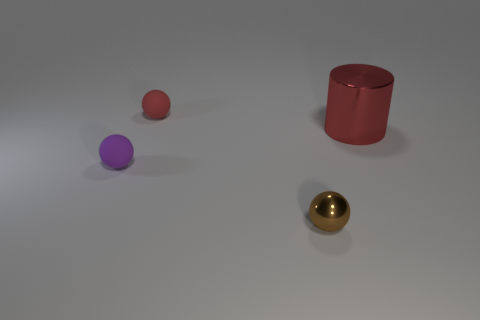Are there any objects that have the same material as the brown ball?
Provide a short and direct response. Yes. There is a tiny object that is in front of the tiny purple rubber object; what shape is it?
Keep it short and to the point. Sphere. There is a small matte thing behind the large red cylinder; is it the same color as the large cylinder?
Make the answer very short. Yes. Are there fewer red things on the left side of the purple object than brown balls?
Keep it short and to the point. Yes. The small thing that is made of the same material as the tiny purple sphere is what color?
Provide a short and direct response. Red. There is a ball in front of the tiny purple rubber thing; what size is it?
Make the answer very short. Small. Are the red cylinder and the purple object made of the same material?
Provide a succinct answer. No. There is a small thing that is behind the metallic thing that is behind the tiny shiny ball; are there any red things that are in front of it?
Your response must be concise. Yes. What is the color of the big shiny thing?
Your answer should be compact. Red. What is the color of the other shiny object that is the same size as the purple thing?
Provide a short and direct response. Brown. 